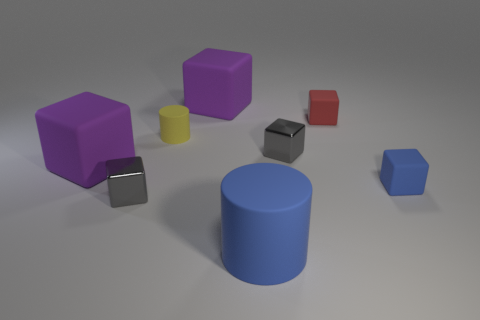Subtract all small gray blocks. How many blocks are left? 4 Subtract all purple cubes. How many cubes are left? 4 Add 2 gray rubber cylinders. How many objects exist? 10 Subtract all cylinders. How many objects are left? 6 Subtract 5 cubes. How many cubes are left? 1 Subtract all green cubes. Subtract all brown cylinders. How many cubes are left? 6 Subtract all purple blocks. How many cyan cylinders are left? 0 Subtract all cyan matte cylinders. Subtract all tiny blue blocks. How many objects are left? 7 Add 2 large matte cylinders. How many large matte cylinders are left? 3 Add 2 red matte objects. How many red matte objects exist? 3 